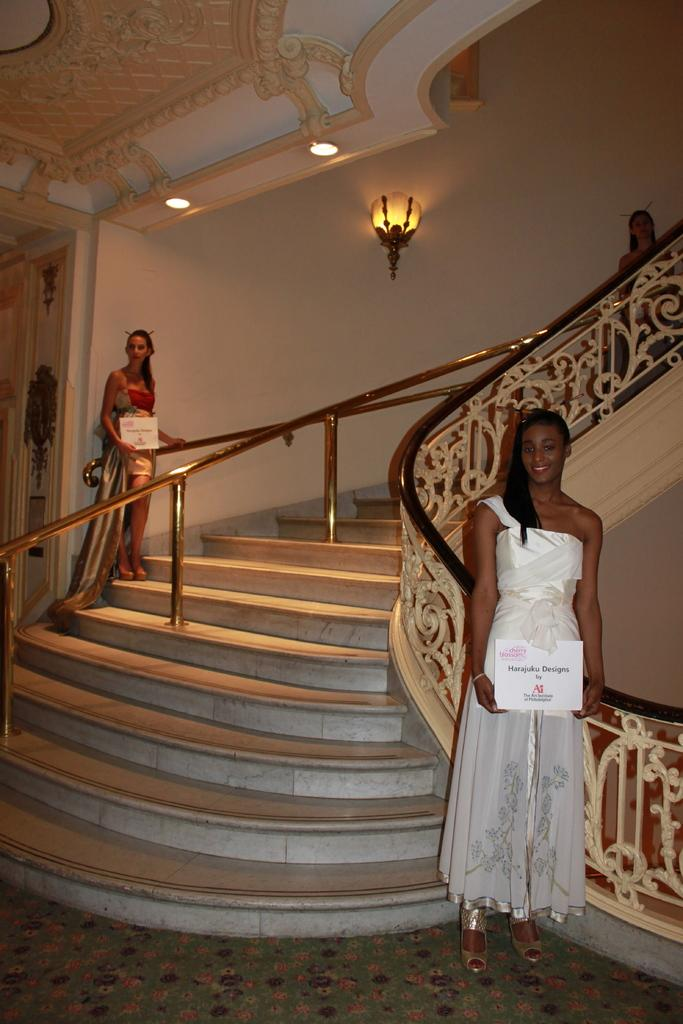How many women are in the image? There are two women standing in the image. What are the women holding in the image? The women are holding boards in the image. What architectural feature can be seen in the image? There are steps in the image. What is located on the left side of the image? There is a door on the left side of the image. What is visible in the background of the image? There is a wall in the background of the image. What is visible at the top of the image? There are lights visible at the top of the image. Can you tell me how many chairs are visible in the image? There are no chairs visible in the image. What type of cemetery can be seen in the background of the image? There is no cemetery present in the image; it features a wall in the background. 